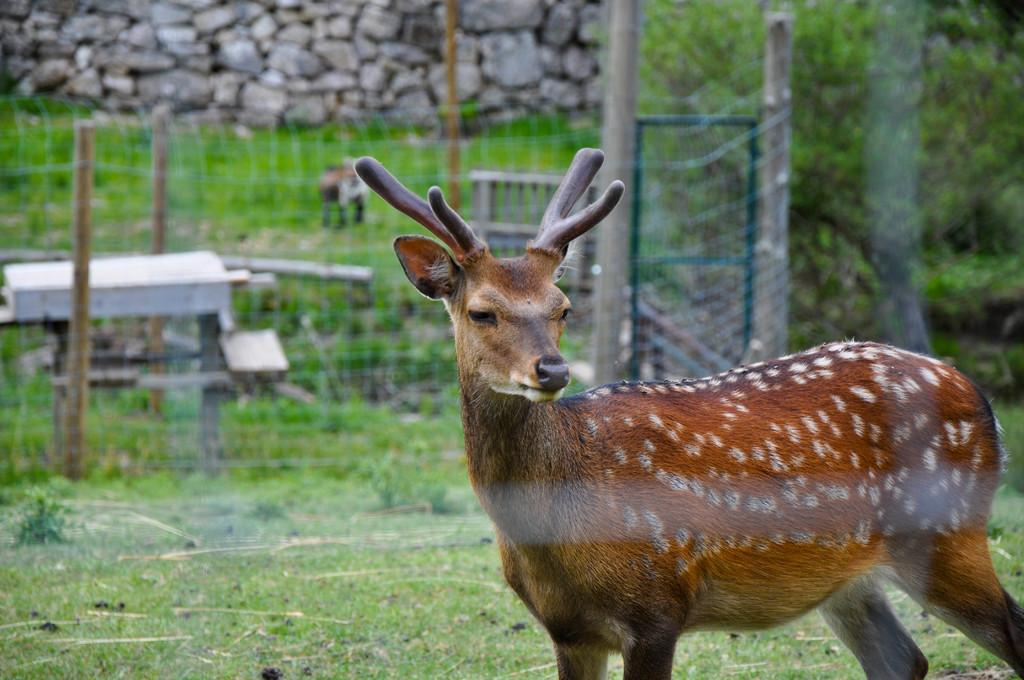What animal can be seen in the image? There is a deer in the image. What is the color of the deer? The deer is brown in color. Where is the deer located in the image? The deer is standing on the ground. What can be seen in the background of the image? There is a fence and trees in the background of the image. What other feature is present in the image? There is a stone wall in the image. What type of bait is the deer using to catch fish in the image? There is no indication in the image that the deer is trying to catch fish or using any bait. How much muscle mass does the deer have in the image? It is not possible to determine the deer's muscle mass from the image alone. 